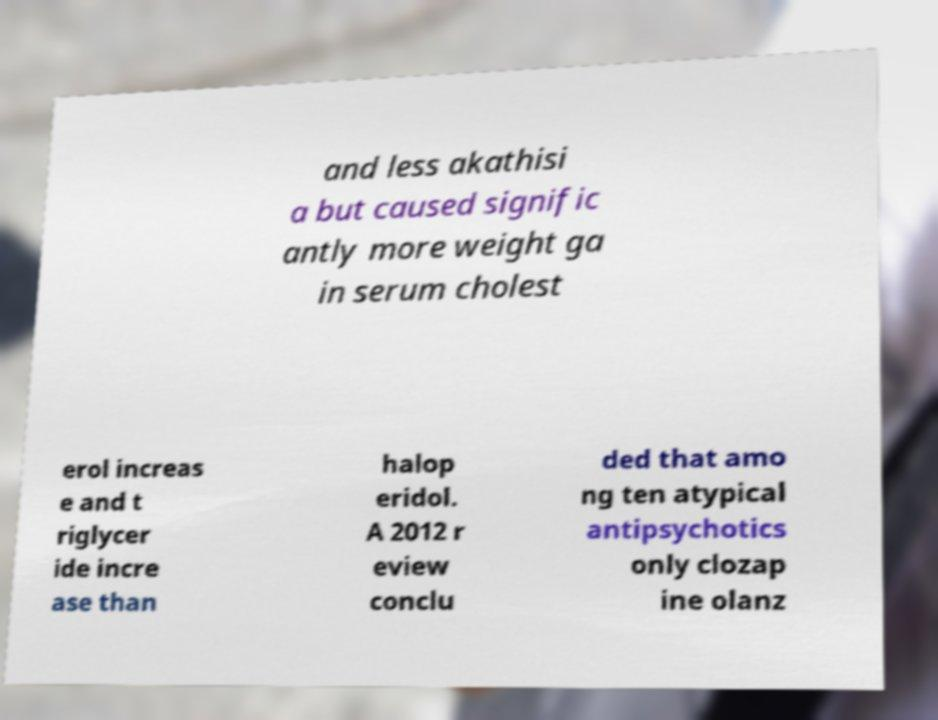I need the written content from this picture converted into text. Can you do that? and less akathisi a but caused signific antly more weight ga in serum cholest erol increas e and t riglycer ide incre ase than halop eridol. A 2012 r eview conclu ded that amo ng ten atypical antipsychotics only clozap ine olanz 